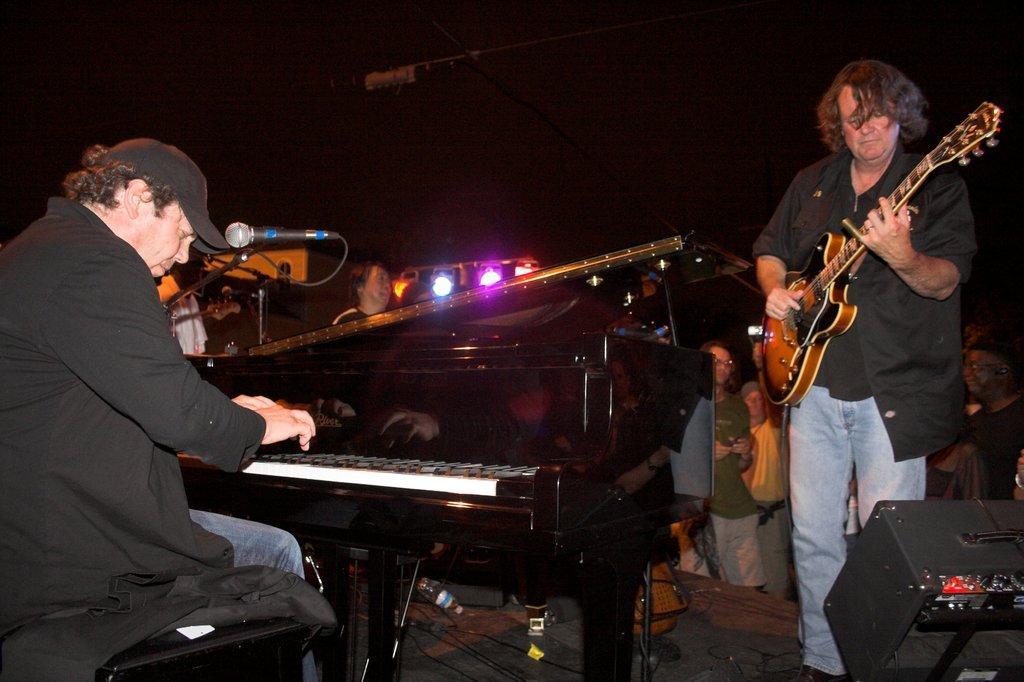Can you describe this image briefly? In this image. On the right there is a man he wear shirt and trouser he is playing guitar. On the left there is a man he is playing piano. In the background there are some people and lights. 